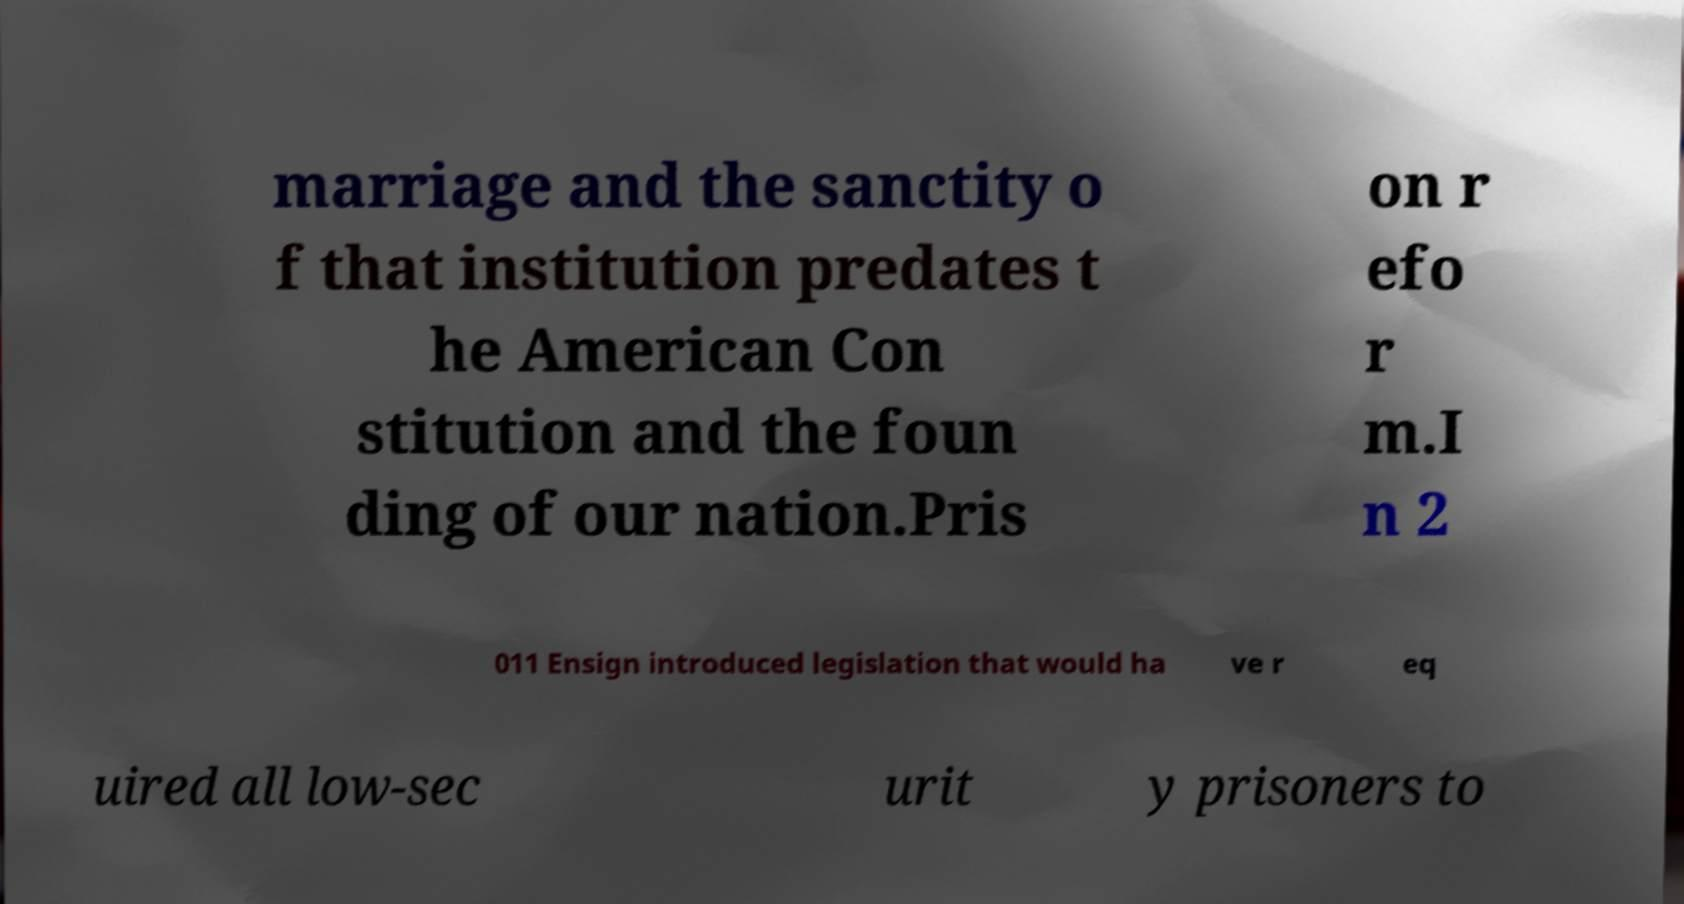Can you accurately transcribe the text from the provided image for me? marriage and the sanctity o f that institution predates t he American Con stitution and the foun ding of our nation.Pris on r efo r m.I n 2 011 Ensign introduced legislation that would ha ve r eq uired all low-sec urit y prisoners to 